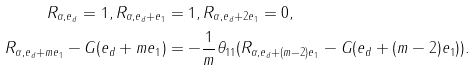<formula> <loc_0><loc_0><loc_500><loc_500>R _ { \alpha , e _ { d } } = 1 , R _ { \alpha , e _ { d } + e _ { 1 } } & = 1 , R _ { \alpha , e _ { d } + 2 e _ { 1 } } = 0 , \\ R _ { \alpha , e _ { d } + m e _ { 1 } } - G ( e _ { d } + m e _ { 1 } ) & = - \frac { 1 } { m } \theta _ { 1 1 } ( R _ { \alpha , e _ { d } + ( m - 2 ) e _ { 1 } } - G ( e _ { d } + ( m - 2 ) e _ { 1 } ) ) .</formula> 